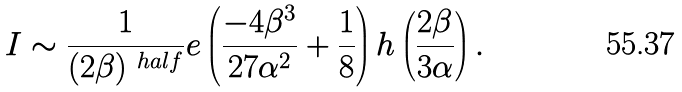<formula> <loc_0><loc_0><loc_500><loc_500>I \sim \frac { 1 } { ( 2 \beta ) ^ { \ h a l f } } e \left ( \frac { - 4 \beta ^ { 3 } } { 2 7 \alpha ^ { 2 } } + \frac { 1 } { 8 } \right ) h \left ( \frac { 2 \beta } { 3 \alpha } \right ) .</formula> 